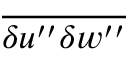<formula> <loc_0><loc_0><loc_500><loc_500>\overline { { { \delta u ^ { \prime \prime } \delta w ^ { \prime \prime } } } }</formula> 